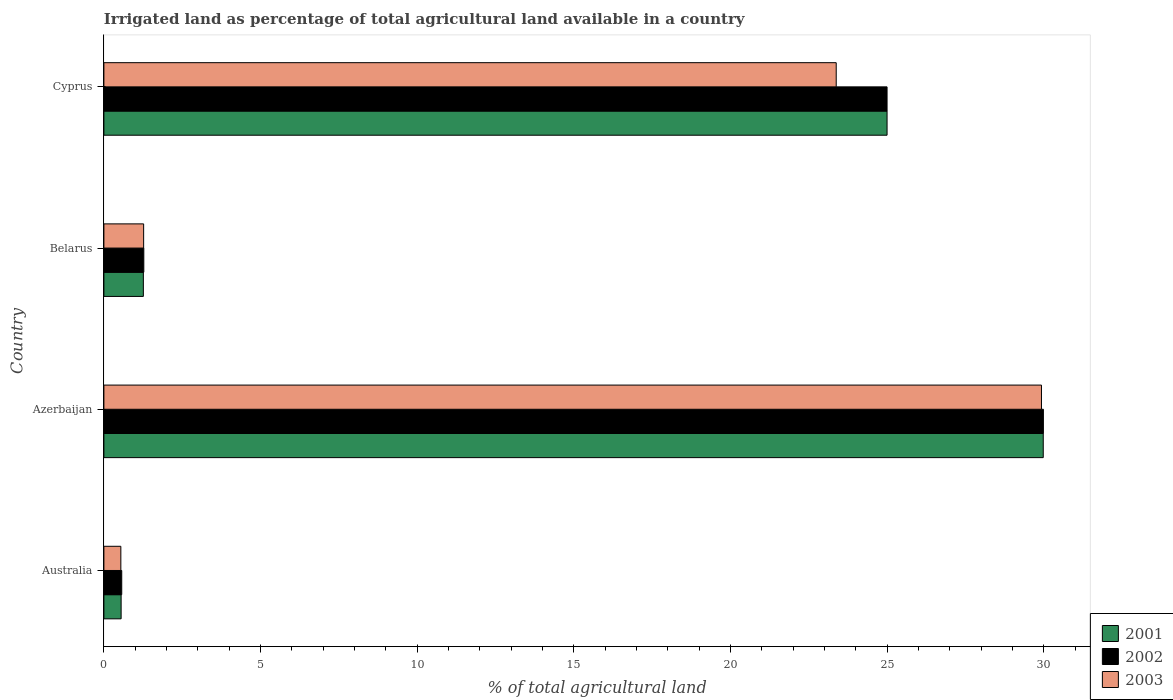How many groups of bars are there?
Ensure brevity in your answer.  4. Are the number of bars per tick equal to the number of legend labels?
Give a very brief answer. Yes. What is the label of the 2nd group of bars from the top?
Provide a short and direct response. Belarus. Across all countries, what is the maximum percentage of irrigated land in 2001?
Offer a very short reply. 29.99. Across all countries, what is the minimum percentage of irrigated land in 2001?
Your response must be concise. 0.55. In which country was the percentage of irrigated land in 2003 maximum?
Keep it short and to the point. Azerbaijan. In which country was the percentage of irrigated land in 2001 minimum?
Make the answer very short. Australia. What is the total percentage of irrigated land in 2001 in the graph?
Ensure brevity in your answer.  56.8. What is the difference between the percentage of irrigated land in 2003 in Australia and that in Azerbaijan?
Provide a succinct answer. -29.39. What is the difference between the percentage of irrigated land in 2002 in Belarus and the percentage of irrigated land in 2003 in Australia?
Keep it short and to the point. 0.73. What is the average percentage of irrigated land in 2003 per country?
Make the answer very short. 13.78. What is the difference between the percentage of irrigated land in 2002 and percentage of irrigated land in 2003 in Belarus?
Make the answer very short. 0.01. In how many countries, is the percentage of irrigated land in 2001 greater than 3 %?
Offer a very short reply. 2. What is the ratio of the percentage of irrigated land in 2001 in Azerbaijan to that in Belarus?
Make the answer very short. 23.8. Is the percentage of irrigated land in 2002 in Azerbaijan less than that in Belarus?
Give a very brief answer. No. What is the difference between the highest and the second highest percentage of irrigated land in 2001?
Give a very brief answer. 4.99. What is the difference between the highest and the lowest percentage of irrigated land in 2001?
Provide a short and direct response. 29.44. Is the sum of the percentage of irrigated land in 2001 in Azerbaijan and Belarus greater than the maximum percentage of irrigated land in 2002 across all countries?
Make the answer very short. Yes. How many bars are there?
Your answer should be very brief. 12. Does the graph contain any zero values?
Your answer should be very brief. No. Where does the legend appear in the graph?
Your response must be concise. Bottom right. What is the title of the graph?
Your response must be concise. Irrigated land as percentage of total agricultural land available in a country. What is the label or title of the X-axis?
Provide a short and direct response. % of total agricultural land. What is the label or title of the Y-axis?
Offer a terse response. Country. What is the % of total agricultural land of 2001 in Australia?
Give a very brief answer. 0.55. What is the % of total agricultural land of 2002 in Australia?
Your response must be concise. 0.57. What is the % of total agricultural land of 2003 in Australia?
Your answer should be very brief. 0.54. What is the % of total agricultural land of 2001 in Azerbaijan?
Make the answer very short. 29.99. What is the % of total agricultural land in 2002 in Azerbaijan?
Your response must be concise. 29.99. What is the % of total agricultural land in 2003 in Azerbaijan?
Your answer should be very brief. 29.93. What is the % of total agricultural land in 2001 in Belarus?
Offer a very short reply. 1.26. What is the % of total agricultural land in 2002 in Belarus?
Offer a terse response. 1.27. What is the % of total agricultural land of 2003 in Belarus?
Provide a succinct answer. 1.27. What is the % of total agricultural land of 2001 in Cyprus?
Make the answer very short. 25. What is the % of total agricultural land of 2003 in Cyprus?
Make the answer very short. 23.38. Across all countries, what is the maximum % of total agricultural land of 2001?
Ensure brevity in your answer.  29.99. Across all countries, what is the maximum % of total agricultural land of 2002?
Offer a very short reply. 29.99. Across all countries, what is the maximum % of total agricultural land of 2003?
Your response must be concise. 29.93. Across all countries, what is the minimum % of total agricultural land of 2001?
Keep it short and to the point. 0.55. Across all countries, what is the minimum % of total agricultural land in 2002?
Keep it short and to the point. 0.57. Across all countries, what is the minimum % of total agricultural land of 2003?
Make the answer very short. 0.54. What is the total % of total agricultural land in 2001 in the graph?
Offer a terse response. 56.8. What is the total % of total agricultural land in 2002 in the graph?
Ensure brevity in your answer.  56.83. What is the total % of total agricultural land in 2003 in the graph?
Give a very brief answer. 55.12. What is the difference between the % of total agricultural land of 2001 in Australia and that in Azerbaijan?
Your answer should be very brief. -29.44. What is the difference between the % of total agricultural land in 2002 in Australia and that in Azerbaijan?
Your response must be concise. -29.42. What is the difference between the % of total agricultural land in 2003 in Australia and that in Azerbaijan?
Give a very brief answer. -29.39. What is the difference between the % of total agricultural land of 2001 in Australia and that in Belarus?
Make the answer very short. -0.71. What is the difference between the % of total agricultural land of 2002 in Australia and that in Belarus?
Keep it short and to the point. -0.7. What is the difference between the % of total agricultural land in 2003 in Australia and that in Belarus?
Provide a succinct answer. -0.73. What is the difference between the % of total agricultural land of 2001 in Australia and that in Cyprus?
Ensure brevity in your answer.  -24.45. What is the difference between the % of total agricultural land in 2002 in Australia and that in Cyprus?
Offer a very short reply. -24.43. What is the difference between the % of total agricultural land in 2003 in Australia and that in Cyprus?
Give a very brief answer. -22.84. What is the difference between the % of total agricultural land of 2001 in Azerbaijan and that in Belarus?
Give a very brief answer. 28.73. What is the difference between the % of total agricultural land in 2002 in Azerbaijan and that in Belarus?
Your answer should be very brief. 28.72. What is the difference between the % of total agricultural land in 2003 in Azerbaijan and that in Belarus?
Your answer should be compact. 28.66. What is the difference between the % of total agricultural land in 2001 in Azerbaijan and that in Cyprus?
Keep it short and to the point. 4.99. What is the difference between the % of total agricultural land in 2002 in Azerbaijan and that in Cyprus?
Offer a terse response. 4.99. What is the difference between the % of total agricultural land in 2003 in Azerbaijan and that in Cyprus?
Keep it short and to the point. 6.55. What is the difference between the % of total agricultural land in 2001 in Belarus and that in Cyprus?
Give a very brief answer. -23.74. What is the difference between the % of total agricultural land in 2002 in Belarus and that in Cyprus?
Offer a very short reply. -23.73. What is the difference between the % of total agricultural land in 2003 in Belarus and that in Cyprus?
Offer a very short reply. -22.11. What is the difference between the % of total agricultural land of 2001 in Australia and the % of total agricultural land of 2002 in Azerbaijan?
Your response must be concise. -29.44. What is the difference between the % of total agricultural land in 2001 in Australia and the % of total agricultural land in 2003 in Azerbaijan?
Offer a terse response. -29.38. What is the difference between the % of total agricultural land in 2002 in Australia and the % of total agricultural land in 2003 in Azerbaijan?
Ensure brevity in your answer.  -29.36. What is the difference between the % of total agricultural land in 2001 in Australia and the % of total agricultural land in 2002 in Belarus?
Give a very brief answer. -0.72. What is the difference between the % of total agricultural land in 2001 in Australia and the % of total agricultural land in 2003 in Belarus?
Ensure brevity in your answer.  -0.72. What is the difference between the % of total agricultural land in 2002 in Australia and the % of total agricultural land in 2003 in Belarus?
Your answer should be compact. -0.7. What is the difference between the % of total agricultural land in 2001 in Australia and the % of total agricultural land in 2002 in Cyprus?
Give a very brief answer. -24.45. What is the difference between the % of total agricultural land in 2001 in Australia and the % of total agricultural land in 2003 in Cyprus?
Ensure brevity in your answer.  -22.83. What is the difference between the % of total agricultural land of 2002 in Australia and the % of total agricultural land of 2003 in Cyprus?
Provide a short and direct response. -22.81. What is the difference between the % of total agricultural land of 2001 in Azerbaijan and the % of total agricultural land of 2002 in Belarus?
Offer a very short reply. 28.71. What is the difference between the % of total agricultural land in 2001 in Azerbaijan and the % of total agricultural land in 2003 in Belarus?
Offer a very short reply. 28.72. What is the difference between the % of total agricultural land of 2002 in Azerbaijan and the % of total agricultural land of 2003 in Belarus?
Give a very brief answer. 28.72. What is the difference between the % of total agricultural land in 2001 in Azerbaijan and the % of total agricultural land in 2002 in Cyprus?
Offer a terse response. 4.99. What is the difference between the % of total agricultural land of 2001 in Azerbaijan and the % of total agricultural land of 2003 in Cyprus?
Give a very brief answer. 6.61. What is the difference between the % of total agricultural land of 2002 in Azerbaijan and the % of total agricultural land of 2003 in Cyprus?
Provide a short and direct response. 6.61. What is the difference between the % of total agricultural land in 2001 in Belarus and the % of total agricultural land in 2002 in Cyprus?
Keep it short and to the point. -23.74. What is the difference between the % of total agricultural land in 2001 in Belarus and the % of total agricultural land in 2003 in Cyprus?
Give a very brief answer. -22.12. What is the difference between the % of total agricultural land of 2002 in Belarus and the % of total agricultural land of 2003 in Cyprus?
Your answer should be compact. -22.1. What is the average % of total agricultural land in 2001 per country?
Your response must be concise. 14.2. What is the average % of total agricultural land in 2002 per country?
Give a very brief answer. 14.21. What is the average % of total agricultural land of 2003 per country?
Provide a short and direct response. 13.78. What is the difference between the % of total agricultural land in 2001 and % of total agricultural land in 2002 in Australia?
Your answer should be compact. -0.02. What is the difference between the % of total agricultural land of 2001 and % of total agricultural land of 2003 in Australia?
Provide a short and direct response. 0.01. What is the difference between the % of total agricultural land in 2002 and % of total agricultural land in 2003 in Australia?
Provide a short and direct response. 0.03. What is the difference between the % of total agricultural land of 2001 and % of total agricultural land of 2002 in Azerbaijan?
Ensure brevity in your answer.  -0. What is the difference between the % of total agricultural land of 2001 and % of total agricultural land of 2003 in Azerbaijan?
Make the answer very short. 0.06. What is the difference between the % of total agricultural land in 2002 and % of total agricultural land in 2003 in Azerbaijan?
Offer a very short reply. 0.06. What is the difference between the % of total agricultural land in 2001 and % of total agricultural land in 2002 in Belarus?
Make the answer very short. -0.01. What is the difference between the % of total agricultural land in 2001 and % of total agricultural land in 2003 in Belarus?
Ensure brevity in your answer.  -0.01. What is the difference between the % of total agricultural land of 2002 and % of total agricultural land of 2003 in Belarus?
Your answer should be very brief. 0.01. What is the difference between the % of total agricultural land of 2001 and % of total agricultural land of 2003 in Cyprus?
Provide a short and direct response. 1.62. What is the difference between the % of total agricultural land of 2002 and % of total agricultural land of 2003 in Cyprus?
Provide a short and direct response. 1.62. What is the ratio of the % of total agricultural land in 2001 in Australia to that in Azerbaijan?
Offer a very short reply. 0.02. What is the ratio of the % of total agricultural land in 2002 in Australia to that in Azerbaijan?
Your answer should be compact. 0.02. What is the ratio of the % of total agricultural land in 2003 in Australia to that in Azerbaijan?
Ensure brevity in your answer.  0.02. What is the ratio of the % of total agricultural land of 2001 in Australia to that in Belarus?
Keep it short and to the point. 0.44. What is the ratio of the % of total agricultural land of 2002 in Australia to that in Belarus?
Offer a terse response. 0.45. What is the ratio of the % of total agricultural land in 2003 in Australia to that in Belarus?
Provide a succinct answer. 0.43. What is the ratio of the % of total agricultural land in 2001 in Australia to that in Cyprus?
Make the answer very short. 0.02. What is the ratio of the % of total agricultural land in 2002 in Australia to that in Cyprus?
Your answer should be compact. 0.02. What is the ratio of the % of total agricultural land in 2003 in Australia to that in Cyprus?
Your answer should be compact. 0.02. What is the ratio of the % of total agricultural land in 2001 in Azerbaijan to that in Belarus?
Offer a very short reply. 23.8. What is the ratio of the % of total agricultural land in 2002 in Azerbaijan to that in Belarus?
Offer a very short reply. 23.54. What is the ratio of the % of total agricultural land of 2003 in Azerbaijan to that in Belarus?
Offer a terse response. 23.59. What is the ratio of the % of total agricultural land of 2001 in Azerbaijan to that in Cyprus?
Offer a very short reply. 1.2. What is the ratio of the % of total agricultural land in 2002 in Azerbaijan to that in Cyprus?
Your response must be concise. 1.2. What is the ratio of the % of total agricultural land in 2003 in Azerbaijan to that in Cyprus?
Your response must be concise. 1.28. What is the ratio of the % of total agricultural land in 2001 in Belarus to that in Cyprus?
Keep it short and to the point. 0.05. What is the ratio of the % of total agricultural land of 2002 in Belarus to that in Cyprus?
Offer a very short reply. 0.05. What is the ratio of the % of total agricultural land in 2003 in Belarus to that in Cyprus?
Give a very brief answer. 0.05. What is the difference between the highest and the second highest % of total agricultural land of 2001?
Give a very brief answer. 4.99. What is the difference between the highest and the second highest % of total agricultural land of 2002?
Your response must be concise. 4.99. What is the difference between the highest and the second highest % of total agricultural land in 2003?
Offer a very short reply. 6.55. What is the difference between the highest and the lowest % of total agricultural land in 2001?
Keep it short and to the point. 29.44. What is the difference between the highest and the lowest % of total agricultural land in 2002?
Provide a short and direct response. 29.42. What is the difference between the highest and the lowest % of total agricultural land of 2003?
Keep it short and to the point. 29.39. 